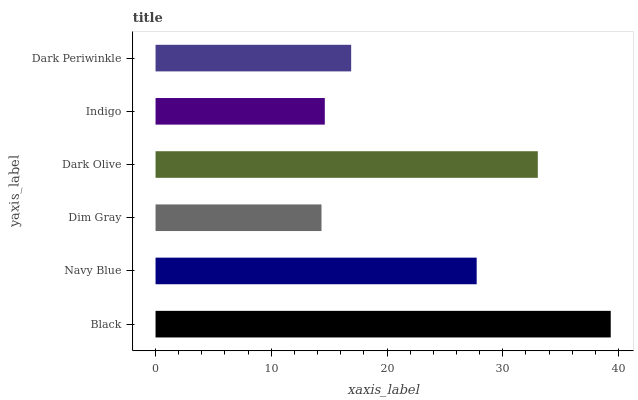Is Dim Gray the minimum?
Answer yes or no. Yes. Is Black the maximum?
Answer yes or no. Yes. Is Navy Blue the minimum?
Answer yes or no. No. Is Navy Blue the maximum?
Answer yes or no. No. Is Black greater than Navy Blue?
Answer yes or no. Yes. Is Navy Blue less than Black?
Answer yes or no. Yes. Is Navy Blue greater than Black?
Answer yes or no. No. Is Black less than Navy Blue?
Answer yes or no. No. Is Navy Blue the high median?
Answer yes or no. Yes. Is Dark Periwinkle the low median?
Answer yes or no. Yes. Is Indigo the high median?
Answer yes or no. No. Is Black the low median?
Answer yes or no. No. 